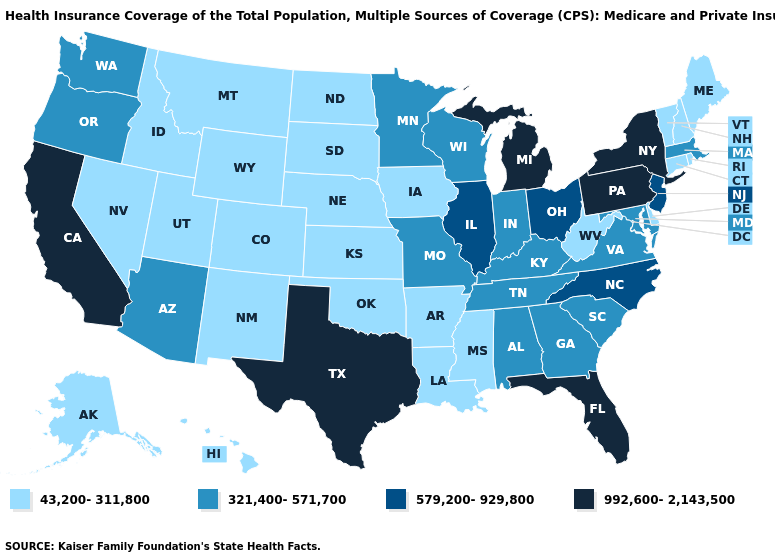What is the lowest value in the MidWest?
Quick response, please. 43,200-311,800. Does California have the highest value in the West?
Quick response, please. Yes. What is the value of Oregon?
Short answer required. 321,400-571,700. Name the states that have a value in the range 579,200-929,800?
Answer briefly. Illinois, New Jersey, North Carolina, Ohio. Does New Hampshire have the lowest value in the USA?
Write a very short answer. Yes. How many symbols are there in the legend?
Be succinct. 4. What is the value of Wisconsin?
Quick response, please. 321,400-571,700. What is the value of Texas?
Write a very short answer. 992,600-2,143,500. Which states hav the highest value in the West?
Concise answer only. California. Which states hav the highest value in the MidWest?
Be succinct. Michigan. What is the value of Montana?
Be succinct. 43,200-311,800. Does the map have missing data?
Concise answer only. No. What is the highest value in the USA?
Answer briefly. 992,600-2,143,500. Does Michigan have the same value as Vermont?
Be succinct. No. 